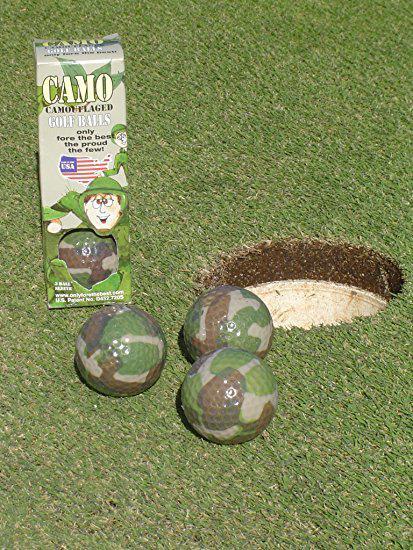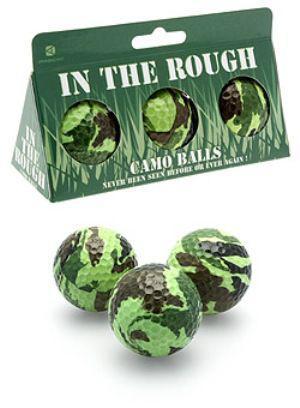The first image is the image on the left, the second image is the image on the right. Evaluate the accuracy of this statement regarding the images: "The image on the right includes a box of three camo patterned golf balls, and the image on the left includes a group of three balls that are not in a package.". Is it true? Answer yes or no. Yes. 